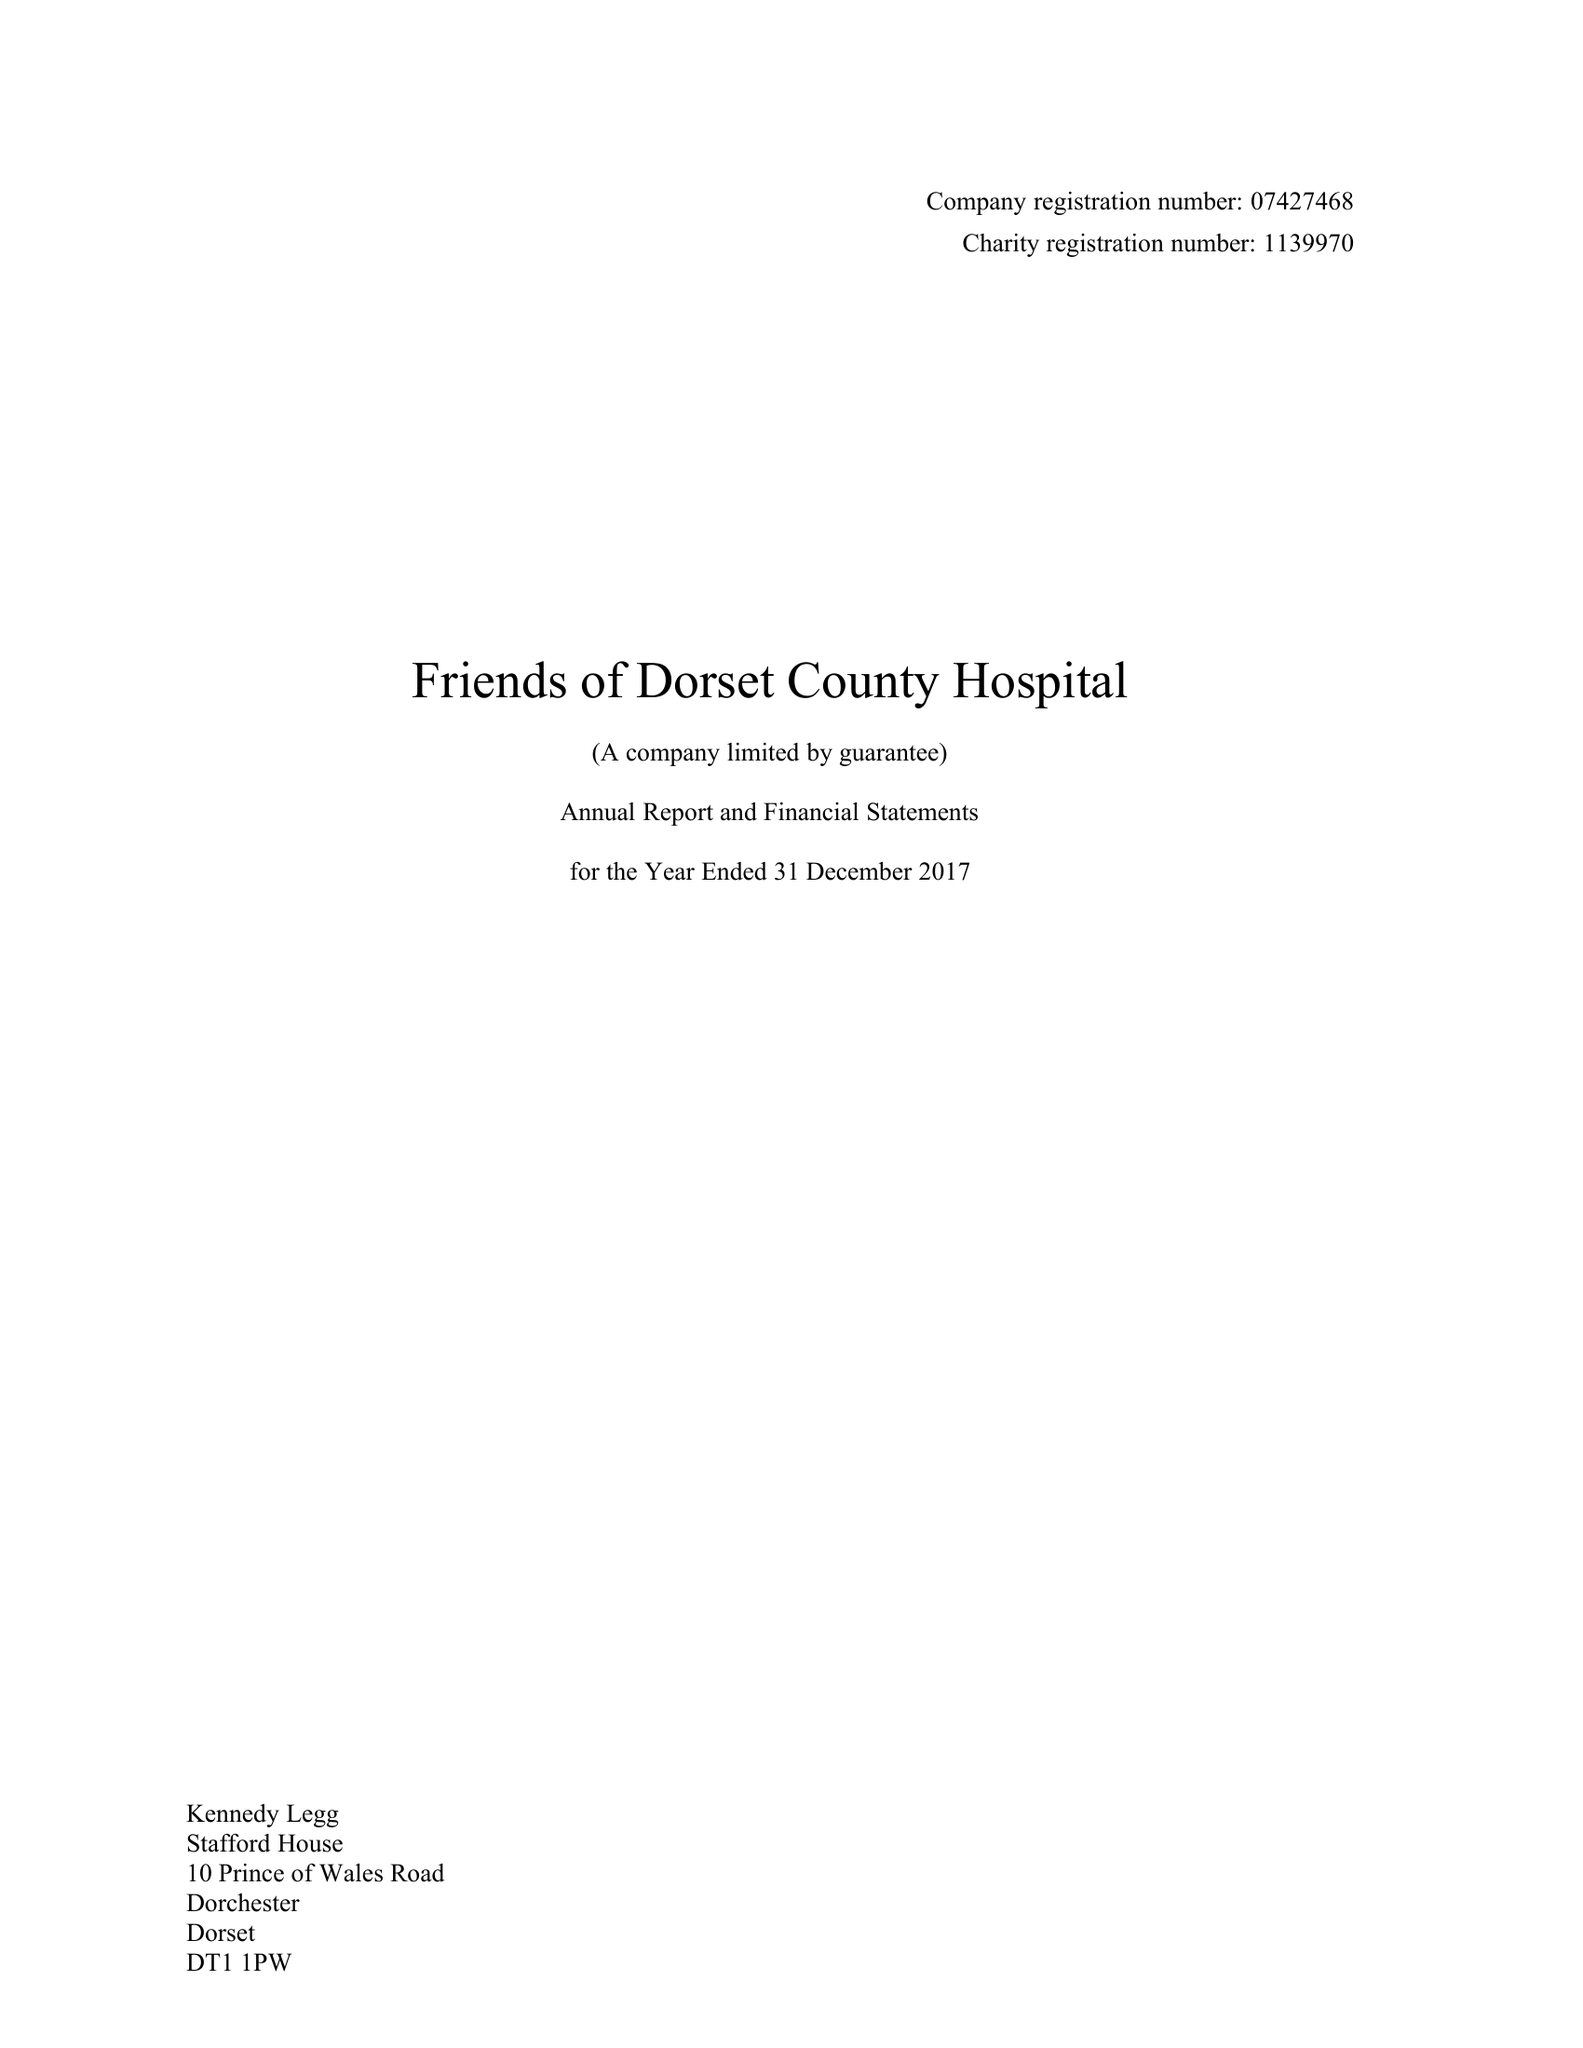What is the value for the charity_name?
Answer the question using a single word or phrase. Friends Of Dorset County Hospital 